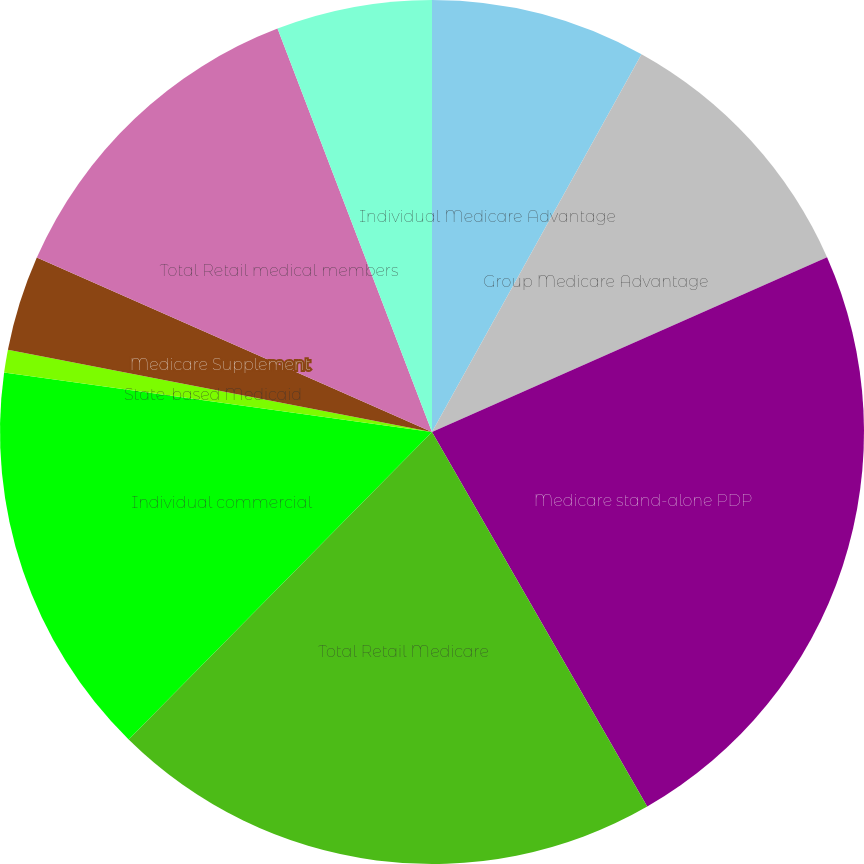<chart> <loc_0><loc_0><loc_500><loc_500><pie_chart><fcel>Individual Medicare Advantage<fcel>Group Medicare Advantage<fcel>Medicare stand-alone PDP<fcel>Total Retail Medicare<fcel>Individual commercial<fcel>State-based Medicaid<fcel>Medicare Supplement<fcel>Total Retail medical members<fcel>Individual specialty<nl><fcel>8.06%<fcel>10.31%<fcel>23.33%<fcel>20.69%<fcel>14.81%<fcel>0.85%<fcel>3.57%<fcel>12.56%<fcel>5.82%<nl></chart> 